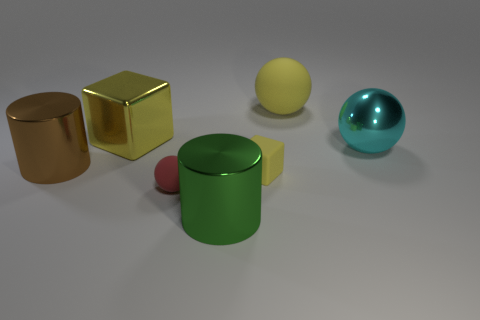What number of purple things are large blocks or big matte things?
Provide a succinct answer. 0. Do the cube that is to the left of the small block and the red sphere have the same material?
Offer a terse response. No. How many things are either small yellow metal cubes or big shiny things to the right of the large brown cylinder?
Offer a terse response. 3. There is a big metal cylinder behind the shiny cylinder that is to the right of the red matte thing; how many large brown objects are on the left side of it?
Your answer should be compact. 0. There is a tiny rubber thing that is behind the red sphere; is its shape the same as the yellow shiny thing?
Ensure brevity in your answer.  Yes. Is there a shiny cylinder behind the yellow thing in front of the metal ball?
Offer a terse response. Yes. What number of gray shiny spheres are there?
Ensure brevity in your answer.  0. There is a metal object that is behind the small red rubber sphere and in front of the big cyan shiny object; what is its color?
Ensure brevity in your answer.  Brown. What size is the other metallic thing that is the same shape as the big green metal thing?
Your response must be concise. Large. What number of objects have the same size as the cyan sphere?
Give a very brief answer. 4. 